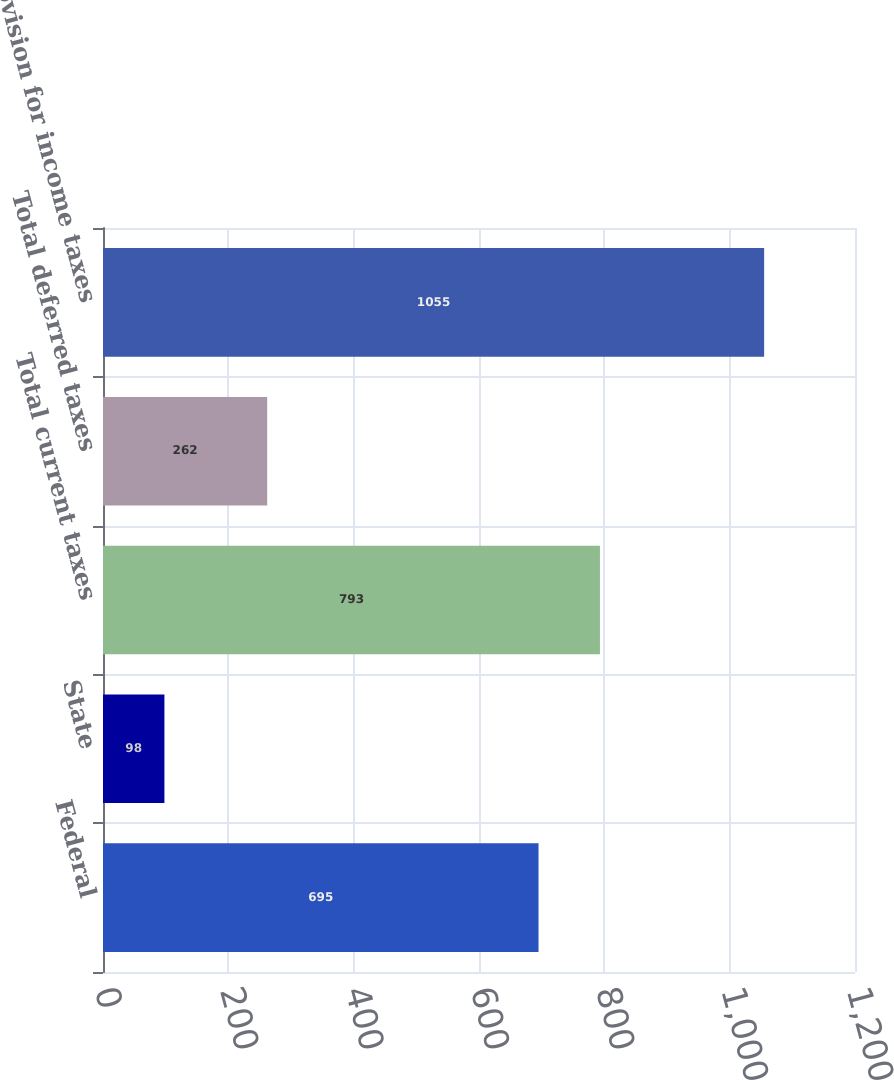Convert chart. <chart><loc_0><loc_0><loc_500><loc_500><bar_chart><fcel>Federal<fcel>State<fcel>Total current taxes<fcel>Total deferred taxes<fcel>Provision for income taxes<nl><fcel>695<fcel>98<fcel>793<fcel>262<fcel>1055<nl></chart> 